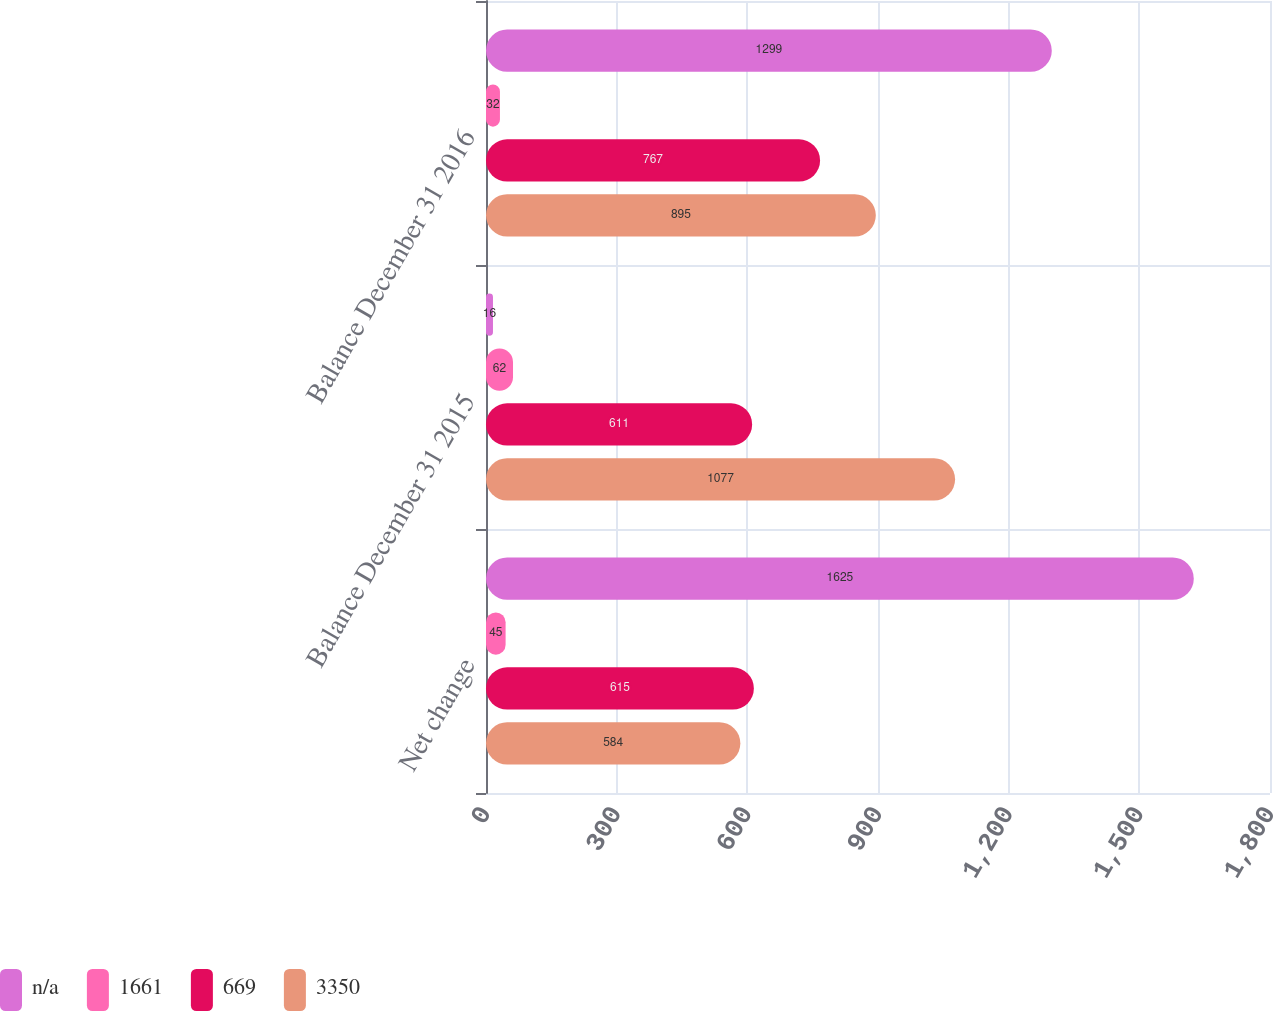<chart> <loc_0><loc_0><loc_500><loc_500><stacked_bar_chart><ecel><fcel>Net change<fcel>Balance December 31 2015<fcel>Balance December 31 2016<nl><fcel>nan<fcel>1625<fcel>16<fcel>1299<nl><fcel>1661<fcel>45<fcel>62<fcel>32<nl><fcel>669<fcel>615<fcel>611<fcel>767<nl><fcel>3350<fcel>584<fcel>1077<fcel>895<nl></chart> 